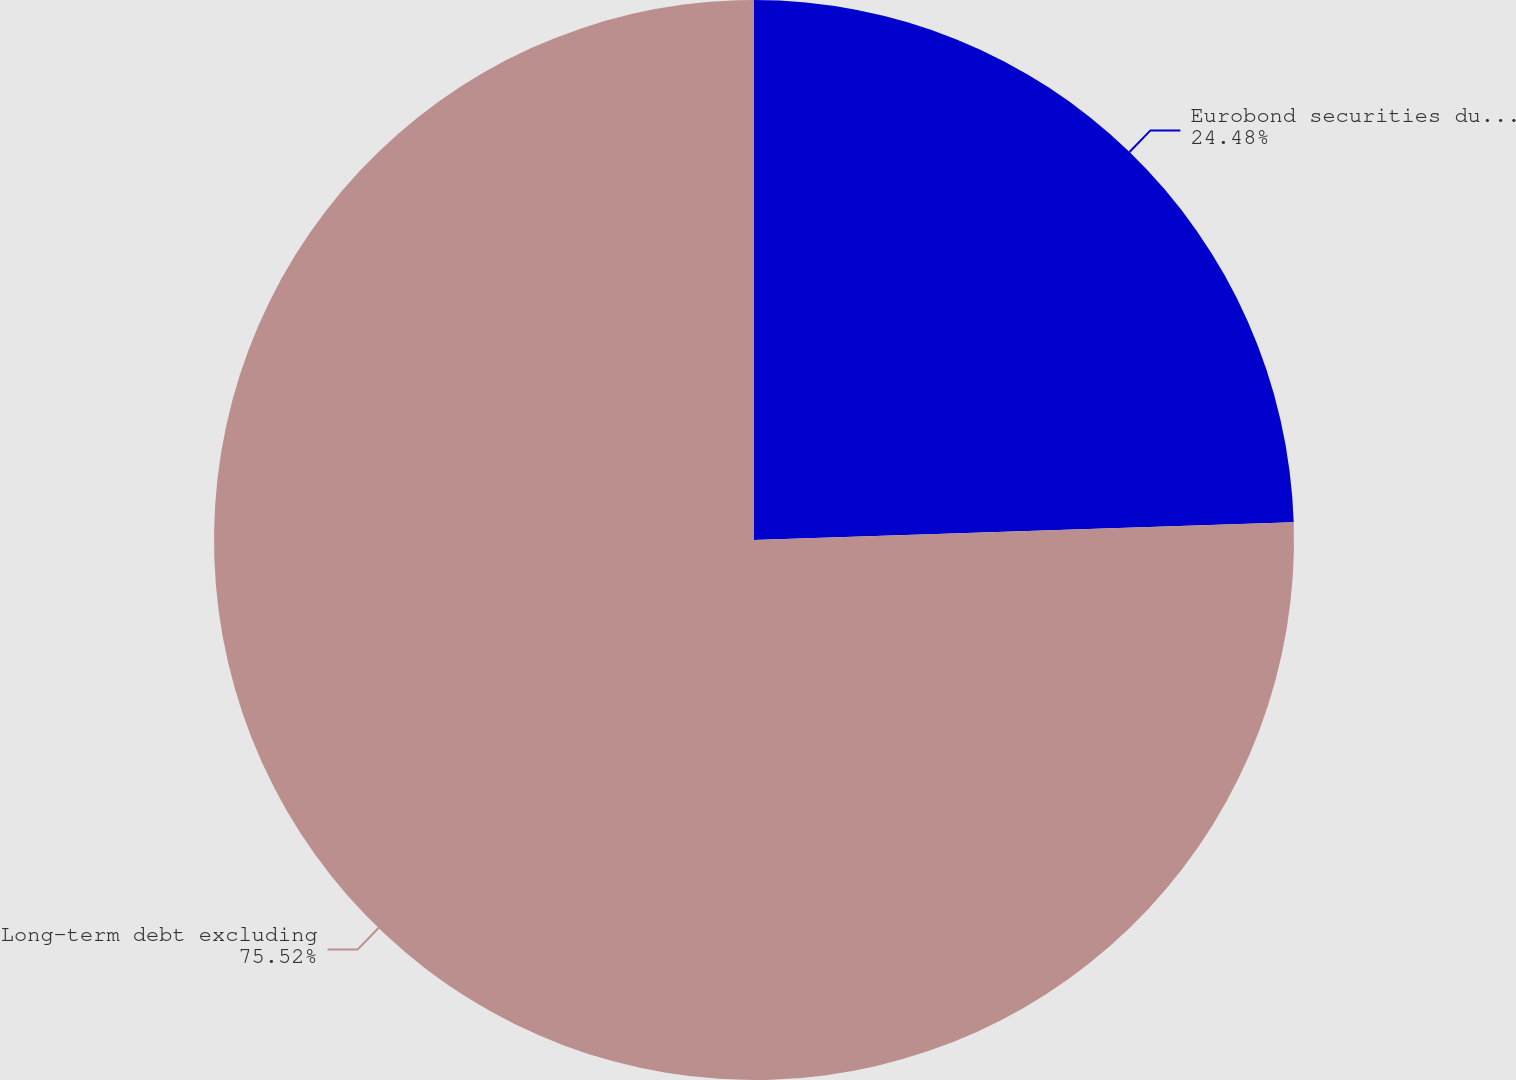<chart> <loc_0><loc_0><loc_500><loc_500><pie_chart><fcel>Eurobond securities due 2014<fcel>Long-term debt excluding<nl><fcel>24.48%<fcel>75.52%<nl></chart> 